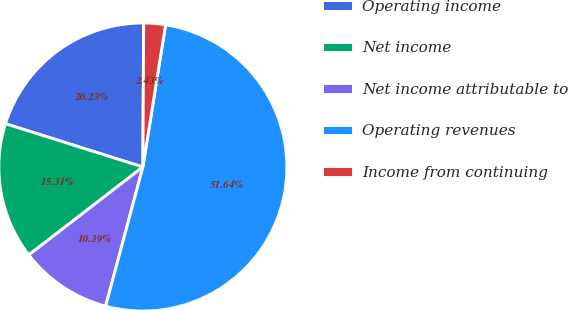Convert chart. <chart><loc_0><loc_0><loc_500><loc_500><pie_chart><fcel>Operating income<fcel>Net income<fcel>Net income attributable to<fcel>Operating revenues<fcel>Income from continuing<nl><fcel>20.23%<fcel>15.31%<fcel>10.39%<fcel>51.65%<fcel>2.43%<nl></chart> 